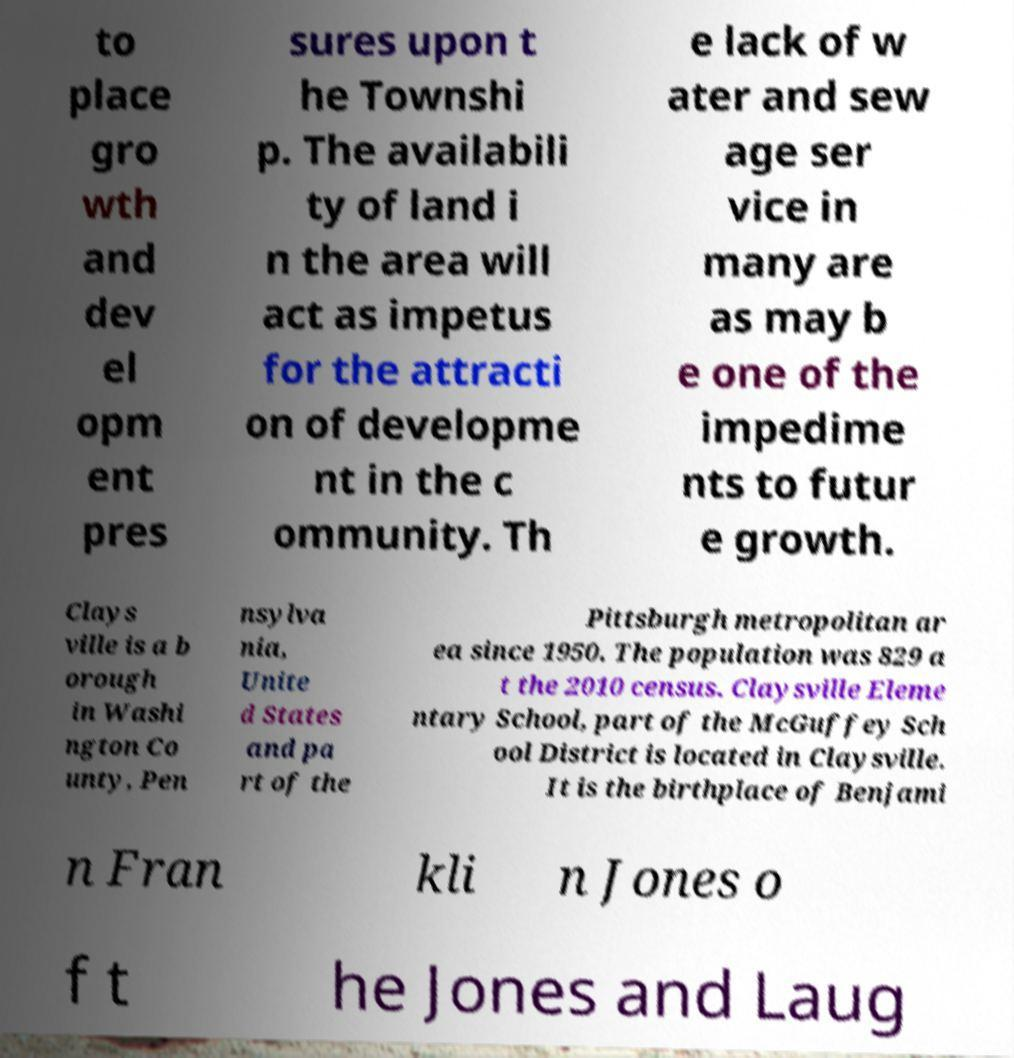Please identify and transcribe the text found in this image. to place gro wth and dev el opm ent pres sures upon t he Townshi p. The availabili ty of land i n the area will act as impetus for the attracti on of developme nt in the c ommunity. Th e lack of w ater and sew age ser vice in many are as may b e one of the impedime nts to futur e growth. Clays ville is a b orough in Washi ngton Co unty, Pen nsylva nia, Unite d States and pa rt of the Pittsburgh metropolitan ar ea since 1950. The population was 829 a t the 2010 census. Claysville Eleme ntary School, part of the McGuffey Sch ool District is located in Claysville. It is the birthplace of Benjami n Fran kli n Jones o f t he Jones and Laug 